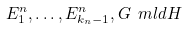<formula> <loc_0><loc_0><loc_500><loc_500>E _ { 1 } ^ { n } , \dots , E _ { k _ { n } - 1 } ^ { n } , G \ m l d H</formula> 